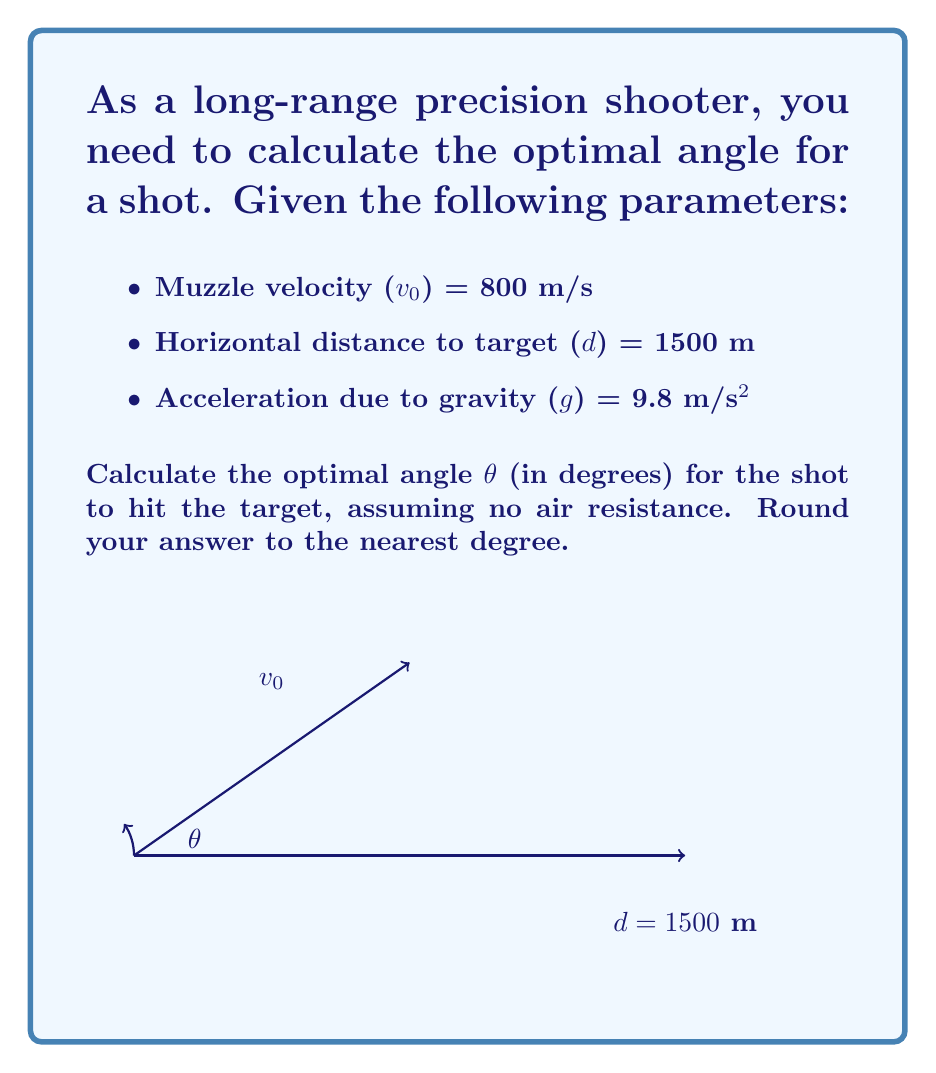Teach me how to tackle this problem. To solve this problem, we'll use the equations of projectile motion and optimize for the angle that gives the maximum range.

1) The range equation for a projectile launched at angle θ is:
   $$R = \frac{v_0^2 \sin(2\theta)}{g}$$

2) We know that the maximum range occurs at θ = 45°. However, since we have a specific target distance, we need to solve for θ:

   $$1500 = \frac{800^2 \sin(2\theta)}{9.8}$$

3) Simplify:
   $$1500 = \frac{640000 \sin(2\theta)}{9.8}$$
   $$14700 = 65306.12 \sin(2\theta)$$

4) Solve for θ:
   $$\sin(2\theta) = \frac{14700}{65306.12} = 0.2250$$
   $$2\theta = \arcsin(0.2250)$$
   $$\theta = \frac{1}{2} \arcsin(0.2250)$$

5) Calculate:
   $$\theta = \frac{1}{2} * 13.0103° = 6.5052°$$

6) Round to the nearest degree:
   θ ≈ 7°

Therefore, the optimal angle for the shot is approximately 7 degrees.
Answer: 7° 